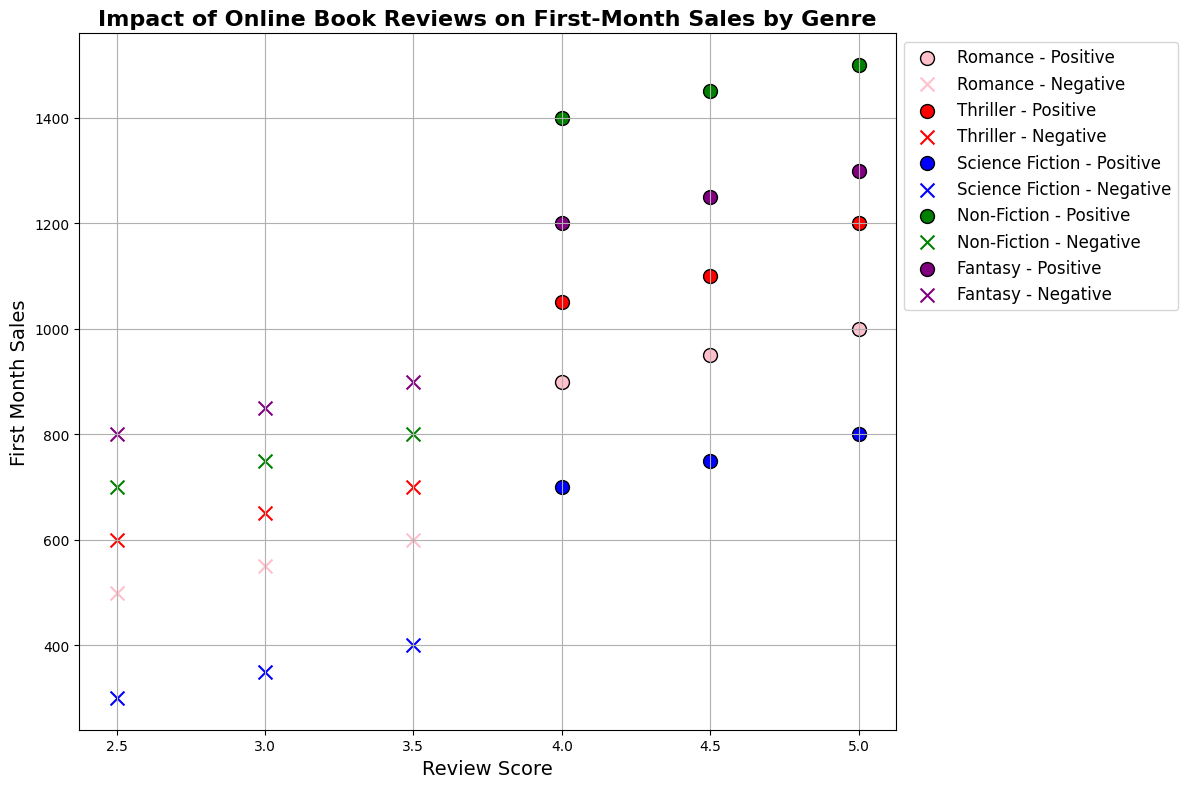How does the first-month sales of Romance books with positive reviews compare to those with negative reviews? To answer this, look for the scatter points for Romance in the chart. Romance books with positive reviews (pink circles) typically have sales ranging from 900 to 1000, while negative reviews (pink crosses) range from 500 to 600. Thus, positive reviews coincide with higher sales.
Answer: Positive reviews have higher sales Which genre has the highest first-month sales for books with positive reviews? Find the highest scatter point among the positive reviews in different colors. Non-Fiction (green circles) reaches the highest sales at around 1500.
Answer: Non-Fiction What is the average first-month sales for Science Fiction books with negative reviews? First, identify the scatter points for Science Fiction negative reviews (blue crosses). The sales are 300, 350, and 400. Calculate the average: (300 + 350 + 400) / 3 = 350.
Answer: 350 Which genre's negative reviews have sales closer to their positive reviews? Compare the relative proximity of negative and positive review points per genre. Fantasy's negative reviews (purple crosses) have sales closer to its positive reviews (purple circles) compared to other genres, with negative around 800-900 and positive 1200-1300.
Answer: Fantasy Is there a stronger correlation between review score and sales in Romance or Thriller? Observe the trend of points for both genres. Romance (pink) and Thriller (red) both show increasing sales with positive reviews, but Thriller seems more consistent in showing this correlation, especially for positive reviews.
Answer: Thriller What is the range of sales for Non-Fiction books with negative reviews? Look for the Non-Fiction negative reviews (green crosses), with sales at 700, 750, and 800. The range is 800 - 700 = 100.
Answer: 100 Does every genre’s positive review scores correspond to higher first-month sales compared to their negative reviews? Check for all colored circles (positive) and crosses (negative). For all genres, positive reviews consistently show higher sales than negative ones.
Answer: Yes What is the interquartile range (IQR) of the first-month sales of Fantasy books with positive reviews? Identify the positive reviews (purple circles) with sales of 1200, 1250, and 1300. For IQR, Q1=1225, Q3=1275. So, IQR = 1275 - 1225 = 50.
Answer: 50 For which genre does the first-month sale decrease more drastically as the review score decreases from positive to negative? Compare how steeply sales drop from the highest positive score to the lowest negative score. Science Fiction's sales drop drastically from around 800 to 300, indicating a steep decline.
Answer: Science Fiction 